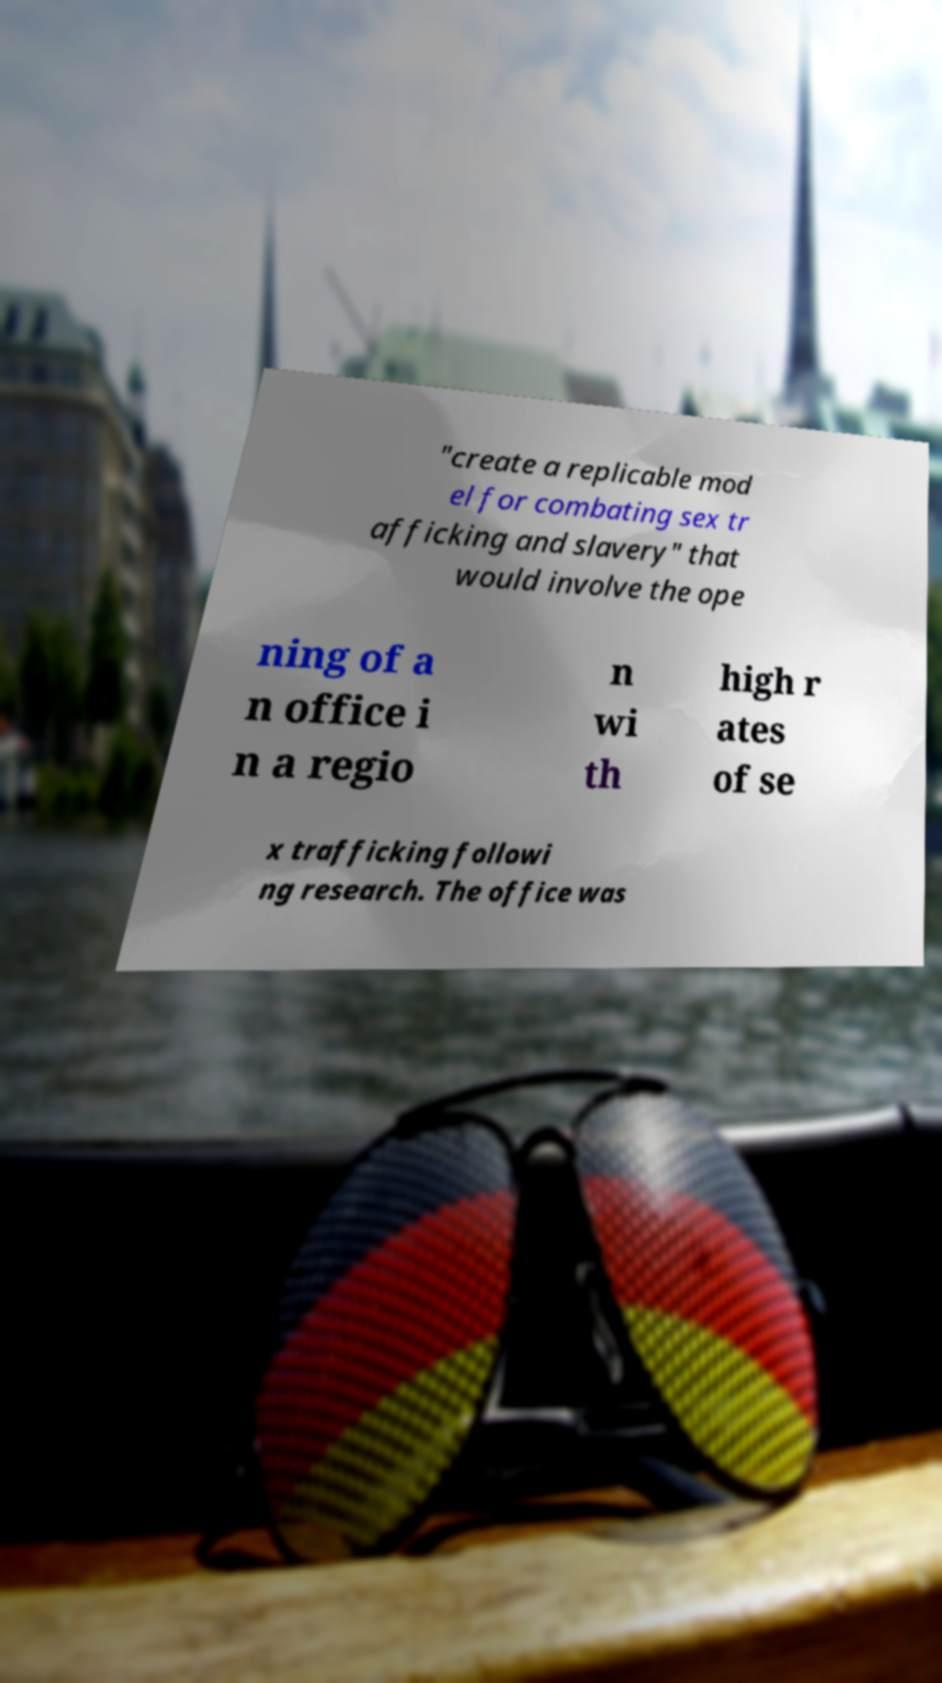Please read and relay the text visible in this image. What does it say? "create a replicable mod el for combating sex tr afficking and slavery" that would involve the ope ning of a n office i n a regio n wi th high r ates of se x trafficking followi ng research. The office was 